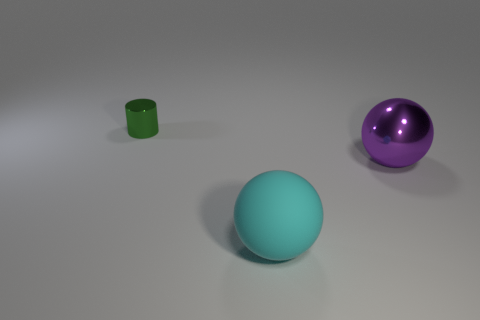There is a object that is on the right side of the large sphere in front of the purple metallic ball; what number of purple spheres are in front of it?
Ensure brevity in your answer.  0. What number of balls are either big rubber objects or blue objects?
Your answer should be very brief. 1. There is a ball that is in front of the metallic thing to the right of the thing on the left side of the cyan matte object; what color is it?
Provide a succinct answer. Cyan. How many other objects are the same size as the purple sphere?
Your response must be concise. 1. Are there any other things that are the same shape as the large cyan rubber thing?
Your answer should be compact. Yes. What color is the shiny thing that is the same shape as the rubber object?
Keep it short and to the point. Purple. What color is the cylinder that is made of the same material as the purple sphere?
Provide a short and direct response. Green. Are there the same number of matte balls behind the green metallic cylinder and small gray metallic objects?
Your answer should be compact. Yes. Does the shiny thing that is behind the purple shiny object have the same size as the large matte sphere?
Offer a terse response. No. The matte object that is the same size as the purple shiny sphere is what color?
Your answer should be very brief. Cyan. 